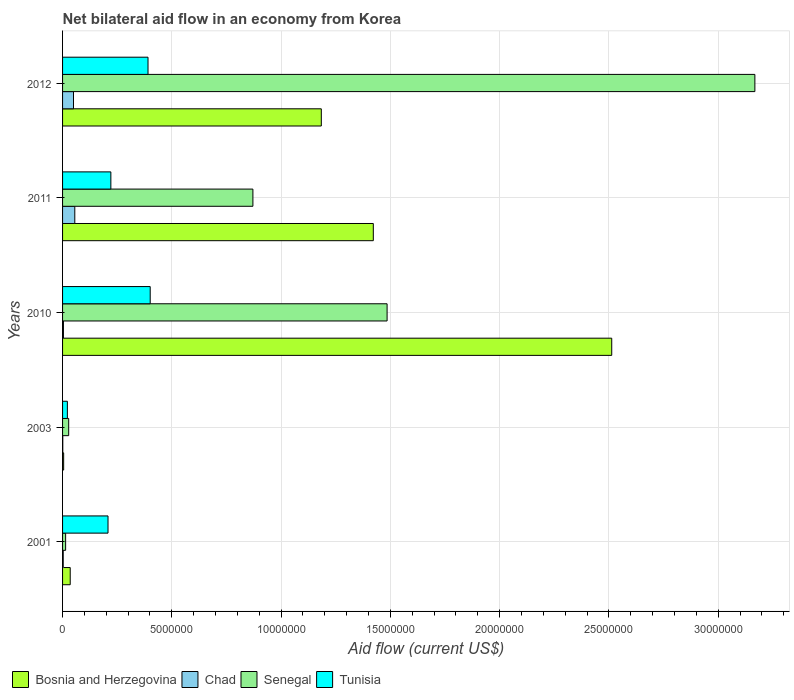How many different coloured bars are there?
Your response must be concise. 4. How many bars are there on the 2nd tick from the bottom?
Make the answer very short. 4. What is the label of the 2nd group of bars from the top?
Make the answer very short. 2011. In how many cases, is the number of bars for a given year not equal to the number of legend labels?
Provide a short and direct response. 0. What is the net bilateral aid flow in Bosnia and Herzegovina in 2012?
Make the answer very short. 1.18e+07. Across all years, what is the maximum net bilateral aid flow in Tunisia?
Offer a very short reply. 4.01e+06. What is the total net bilateral aid flow in Tunisia in the graph?
Provide a succinct answer. 1.24e+07. What is the difference between the net bilateral aid flow in Bosnia and Herzegovina in 2003 and that in 2012?
Your response must be concise. -1.18e+07. What is the difference between the net bilateral aid flow in Senegal in 2010 and the net bilateral aid flow in Tunisia in 2001?
Keep it short and to the point. 1.28e+07. What is the average net bilateral aid flow in Chad per year?
Your answer should be very brief. 2.28e+05. In the year 2010, what is the difference between the net bilateral aid flow in Chad and net bilateral aid flow in Senegal?
Provide a short and direct response. -1.48e+07. In how many years, is the net bilateral aid flow in Tunisia greater than 1000000 US$?
Provide a short and direct response. 4. Is the difference between the net bilateral aid flow in Chad in 2010 and 2012 greater than the difference between the net bilateral aid flow in Senegal in 2010 and 2012?
Your answer should be compact. Yes. What is the difference between the highest and the second highest net bilateral aid flow in Chad?
Your response must be concise. 6.00e+04. What is the difference between the highest and the lowest net bilateral aid flow in Bosnia and Herzegovina?
Provide a succinct answer. 2.51e+07. In how many years, is the net bilateral aid flow in Bosnia and Herzegovina greater than the average net bilateral aid flow in Bosnia and Herzegovina taken over all years?
Your answer should be compact. 3. Is it the case that in every year, the sum of the net bilateral aid flow in Senegal and net bilateral aid flow in Bosnia and Herzegovina is greater than the sum of net bilateral aid flow in Tunisia and net bilateral aid flow in Chad?
Give a very brief answer. No. What does the 1st bar from the top in 2012 represents?
Your answer should be very brief. Tunisia. What does the 3rd bar from the bottom in 2012 represents?
Your answer should be compact. Senegal. Is it the case that in every year, the sum of the net bilateral aid flow in Bosnia and Herzegovina and net bilateral aid flow in Chad is greater than the net bilateral aid flow in Tunisia?
Ensure brevity in your answer.  No. How many bars are there?
Provide a short and direct response. 20. Are all the bars in the graph horizontal?
Provide a succinct answer. Yes. How many years are there in the graph?
Give a very brief answer. 5. What is the difference between two consecutive major ticks on the X-axis?
Offer a very short reply. 5.00e+06. Are the values on the major ticks of X-axis written in scientific E-notation?
Provide a short and direct response. No. What is the title of the graph?
Your answer should be compact. Net bilateral aid flow in an economy from Korea. What is the Aid flow (current US$) in Senegal in 2001?
Provide a short and direct response. 1.40e+05. What is the Aid flow (current US$) of Tunisia in 2001?
Ensure brevity in your answer.  2.08e+06. What is the Aid flow (current US$) of Chad in 2003?
Provide a succinct answer. 10000. What is the Aid flow (current US$) in Bosnia and Herzegovina in 2010?
Offer a terse response. 2.51e+07. What is the Aid flow (current US$) of Chad in 2010?
Your answer should be very brief. 4.00e+04. What is the Aid flow (current US$) of Senegal in 2010?
Your answer should be compact. 1.48e+07. What is the Aid flow (current US$) of Tunisia in 2010?
Offer a very short reply. 4.01e+06. What is the Aid flow (current US$) in Bosnia and Herzegovina in 2011?
Ensure brevity in your answer.  1.42e+07. What is the Aid flow (current US$) in Chad in 2011?
Keep it short and to the point. 5.60e+05. What is the Aid flow (current US$) in Senegal in 2011?
Make the answer very short. 8.71e+06. What is the Aid flow (current US$) of Tunisia in 2011?
Provide a succinct answer. 2.21e+06. What is the Aid flow (current US$) of Bosnia and Herzegovina in 2012?
Your answer should be very brief. 1.18e+07. What is the Aid flow (current US$) in Chad in 2012?
Your response must be concise. 5.00e+05. What is the Aid flow (current US$) in Senegal in 2012?
Your answer should be compact. 3.17e+07. What is the Aid flow (current US$) of Tunisia in 2012?
Provide a succinct answer. 3.91e+06. Across all years, what is the maximum Aid flow (current US$) of Bosnia and Herzegovina?
Your answer should be compact. 2.51e+07. Across all years, what is the maximum Aid flow (current US$) in Chad?
Give a very brief answer. 5.60e+05. Across all years, what is the maximum Aid flow (current US$) of Senegal?
Your answer should be very brief. 3.17e+07. Across all years, what is the maximum Aid flow (current US$) of Tunisia?
Your answer should be very brief. 4.01e+06. Across all years, what is the minimum Aid flow (current US$) in Bosnia and Herzegovina?
Keep it short and to the point. 5.00e+04. Across all years, what is the minimum Aid flow (current US$) of Chad?
Give a very brief answer. 10000. Across all years, what is the minimum Aid flow (current US$) in Senegal?
Offer a very short reply. 1.40e+05. What is the total Aid flow (current US$) of Bosnia and Herzegovina in the graph?
Provide a succinct answer. 5.16e+07. What is the total Aid flow (current US$) of Chad in the graph?
Keep it short and to the point. 1.14e+06. What is the total Aid flow (current US$) of Senegal in the graph?
Give a very brief answer. 5.57e+07. What is the total Aid flow (current US$) in Tunisia in the graph?
Keep it short and to the point. 1.24e+07. What is the difference between the Aid flow (current US$) in Chad in 2001 and that in 2003?
Your response must be concise. 2.00e+04. What is the difference between the Aid flow (current US$) of Tunisia in 2001 and that in 2003?
Your response must be concise. 1.86e+06. What is the difference between the Aid flow (current US$) in Bosnia and Herzegovina in 2001 and that in 2010?
Provide a succinct answer. -2.48e+07. What is the difference between the Aid flow (current US$) in Chad in 2001 and that in 2010?
Your answer should be compact. -10000. What is the difference between the Aid flow (current US$) of Senegal in 2001 and that in 2010?
Ensure brevity in your answer.  -1.47e+07. What is the difference between the Aid flow (current US$) of Tunisia in 2001 and that in 2010?
Give a very brief answer. -1.93e+06. What is the difference between the Aid flow (current US$) in Bosnia and Herzegovina in 2001 and that in 2011?
Provide a succinct answer. -1.39e+07. What is the difference between the Aid flow (current US$) in Chad in 2001 and that in 2011?
Your response must be concise. -5.30e+05. What is the difference between the Aid flow (current US$) in Senegal in 2001 and that in 2011?
Provide a short and direct response. -8.57e+06. What is the difference between the Aid flow (current US$) in Tunisia in 2001 and that in 2011?
Your response must be concise. -1.30e+05. What is the difference between the Aid flow (current US$) in Bosnia and Herzegovina in 2001 and that in 2012?
Provide a short and direct response. -1.15e+07. What is the difference between the Aid flow (current US$) in Chad in 2001 and that in 2012?
Provide a short and direct response. -4.70e+05. What is the difference between the Aid flow (current US$) of Senegal in 2001 and that in 2012?
Your response must be concise. -3.15e+07. What is the difference between the Aid flow (current US$) in Tunisia in 2001 and that in 2012?
Ensure brevity in your answer.  -1.83e+06. What is the difference between the Aid flow (current US$) in Bosnia and Herzegovina in 2003 and that in 2010?
Give a very brief answer. -2.51e+07. What is the difference between the Aid flow (current US$) in Senegal in 2003 and that in 2010?
Keep it short and to the point. -1.46e+07. What is the difference between the Aid flow (current US$) in Tunisia in 2003 and that in 2010?
Offer a terse response. -3.79e+06. What is the difference between the Aid flow (current US$) in Bosnia and Herzegovina in 2003 and that in 2011?
Your response must be concise. -1.42e+07. What is the difference between the Aid flow (current US$) in Chad in 2003 and that in 2011?
Ensure brevity in your answer.  -5.50e+05. What is the difference between the Aid flow (current US$) of Senegal in 2003 and that in 2011?
Offer a very short reply. -8.43e+06. What is the difference between the Aid flow (current US$) of Tunisia in 2003 and that in 2011?
Your answer should be compact. -1.99e+06. What is the difference between the Aid flow (current US$) in Bosnia and Herzegovina in 2003 and that in 2012?
Your answer should be very brief. -1.18e+07. What is the difference between the Aid flow (current US$) of Chad in 2003 and that in 2012?
Give a very brief answer. -4.90e+05. What is the difference between the Aid flow (current US$) of Senegal in 2003 and that in 2012?
Your response must be concise. -3.14e+07. What is the difference between the Aid flow (current US$) in Tunisia in 2003 and that in 2012?
Offer a terse response. -3.69e+06. What is the difference between the Aid flow (current US$) in Bosnia and Herzegovina in 2010 and that in 2011?
Provide a succinct answer. 1.09e+07. What is the difference between the Aid flow (current US$) in Chad in 2010 and that in 2011?
Keep it short and to the point. -5.20e+05. What is the difference between the Aid flow (current US$) of Senegal in 2010 and that in 2011?
Your answer should be compact. 6.14e+06. What is the difference between the Aid flow (current US$) of Tunisia in 2010 and that in 2011?
Your answer should be very brief. 1.80e+06. What is the difference between the Aid flow (current US$) in Bosnia and Herzegovina in 2010 and that in 2012?
Ensure brevity in your answer.  1.33e+07. What is the difference between the Aid flow (current US$) in Chad in 2010 and that in 2012?
Offer a very short reply. -4.60e+05. What is the difference between the Aid flow (current US$) of Senegal in 2010 and that in 2012?
Provide a short and direct response. -1.68e+07. What is the difference between the Aid flow (current US$) in Bosnia and Herzegovina in 2011 and that in 2012?
Give a very brief answer. 2.38e+06. What is the difference between the Aid flow (current US$) in Senegal in 2011 and that in 2012?
Your answer should be compact. -2.30e+07. What is the difference between the Aid flow (current US$) in Tunisia in 2011 and that in 2012?
Provide a succinct answer. -1.70e+06. What is the difference between the Aid flow (current US$) of Bosnia and Herzegovina in 2001 and the Aid flow (current US$) of Senegal in 2003?
Offer a very short reply. 7.00e+04. What is the difference between the Aid flow (current US$) in Bosnia and Herzegovina in 2001 and the Aid flow (current US$) in Senegal in 2010?
Your answer should be very brief. -1.45e+07. What is the difference between the Aid flow (current US$) in Bosnia and Herzegovina in 2001 and the Aid flow (current US$) in Tunisia in 2010?
Offer a terse response. -3.66e+06. What is the difference between the Aid flow (current US$) in Chad in 2001 and the Aid flow (current US$) in Senegal in 2010?
Your answer should be very brief. -1.48e+07. What is the difference between the Aid flow (current US$) of Chad in 2001 and the Aid flow (current US$) of Tunisia in 2010?
Ensure brevity in your answer.  -3.98e+06. What is the difference between the Aid flow (current US$) in Senegal in 2001 and the Aid flow (current US$) in Tunisia in 2010?
Make the answer very short. -3.87e+06. What is the difference between the Aid flow (current US$) of Bosnia and Herzegovina in 2001 and the Aid flow (current US$) of Chad in 2011?
Keep it short and to the point. -2.10e+05. What is the difference between the Aid flow (current US$) in Bosnia and Herzegovina in 2001 and the Aid flow (current US$) in Senegal in 2011?
Offer a terse response. -8.36e+06. What is the difference between the Aid flow (current US$) in Bosnia and Herzegovina in 2001 and the Aid flow (current US$) in Tunisia in 2011?
Keep it short and to the point. -1.86e+06. What is the difference between the Aid flow (current US$) in Chad in 2001 and the Aid flow (current US$) in Senegal in 2011?
Offer a very short reply. -8.68e+06. What is the difference between the Aid flow (current US$) in Chad in 2001 and the Aid flow (current US$) in Tunisia in 2011?
Provide a short and direct response. -2.18e+06. What is the difference between the Aid flow (current US$) of Senegal in 2001 and the Aid flow (current US$) of Tunisia in 2011?
Keep it short and to the point. -2.07e+06. What is the difference between the Aid flow (current US$) in Bosnia and Herzegovina in 2001 and the Aid flow (current US$) in Senegal in 2012?
Ensure brevity in your answer.  -3.13e+07. What is the difference between the Aid flow (current US$) of Bosnia and Herzegovina in 2001 and the Aid flow (current US$) of Tunisia in 2012?
Offer a very short reply. -3.56e+06. What is the difference between the Aid flow (current US$) in Chad in 2001 and the Aid flow (current US$) in Senegal in 2012?
Give a very brief answer. -3.16e+07. What is the difference between the Aid flow (current US$) in Chad in 2001 and the Aid flow (current US$) in Tunisia in 2012?
Make the answer very short. -3.88e+06. What is the difference between the Aid flow (current US$) in Senegal in 2001 and the Aid flow (current US$) in Tunisia in 2012?
Ensure brevity in your answer.  -3.77e+06. What is the difference between the Aid flow (current US$) in Bosnia and Herzegovina in 2003 and the Aid flow (current US$) in Senegal in 2010?
Provide a succinct answer. -1.48e+07. What is the difference between the Aid flow (current US$) in Bosnia and Herzegovina in 2003 and the Aid flow (current US$) in Tunisia in 2010?
Provide a short and direct response. -3.96e+06. What is the difference between the Aid flow (current US$) in Chad in 2003 and the Aid flow (current US$) in Senegal in 2010?
Keep it short and to the point. -1.48e+07. What is the difference between the Aid flow (current US$) in Senegal in 2003 and the Aid flow (current US$) in Tunisia in 2010?
Your response must be concise. -3.73e+06. What is the difference between the Aid flow (current US$) of Bosnia and Herzegovina in 2003 and the Aid flow (current US$) of Chad in 2011?
Offer a very short reply. -5.10e+05. What is the difference between the Aid flow (current US$) in Bosnia and Herzegovina in 2003 and the Aid flow (current US$) in Senegal in 2011?
Your answer should be very brief. -8.66e+06. What is the difference between the Aid flow (current US$) in Bosnia and Herzegovina in 2003 and the Aid flow (current US$) in Tunisia in 2011?
Your answer should be compact. -2.16e+06. What is the difference between the Aid flow (current US$) in Chad in 2003 and the Aid flow (current US$) in Senegal in 2011?
Make the answer very short. -8.70e+06. What is the difference between the Aid flow (current US$) in Chad in 2003 and the Aid flow (current US$) in Tunisia in 2011?
Offer a terse response. -2.20e+06. What is the difference between the Aid flow (current US$) of Senegal in 2003 and the Aid flow (current US$) of Tunisia in 2011?
Provide a short and direct response. -1.93e+06. What is the difference between the Aid flow (current US$) in Bosnia and Herzegovina in 2003 and the Aid flow (current US$) in Chad in 2012?
Provide a short and direct response. -4.50e+05. What is the difference between the Aid flow (current US$) in Bosnia and Herzegovina in 2003 and the Aid flow (current US$) in Senegal in 2012?
Make the answer very short. -3.16e+07. What is the difference between the Aid flow (current US$) of Bosnia and Herzegovina in 2003 and the Aid flow (current US$) of Tunisia in 2012?
Give a very brief answer. -3.86e+06. What is the difference between the Aid flow (current US$) of Chad in 2003 and the Aid flow (current US$) of Senegal in 2012?
Your response must be concise. -3.17e+07. What is the difference between the Aid flow (current US$) in Chad in 2003 and the Aid flow (current US$) in Tunisia in 2012?
Ensure brevity in your answer.  -3.90e+06. What is the difference between the Aid flow (current US$) of Senegal in 2003 and the Aid flow (current US$) of Tunisia in 2012?
Keep it short and to the point. -3.63e+06. What is the difference between the Aid flow (current US$) in Bosnia and Herzegovina in 2010 and the Aid flow (current US$) in Chad in 2011?
Your answer should be compact. 2.46e+07. What is the difference between the Aid flow (current US$) in Bosnia and Herzegovina in 2010 and the Aid flow (current US$) in Senegal in 2011?
Make the answer very short. 1.64e+07. What is the difference between the Aid flow (current US$) in Bosnia and Herzegovina in 2010 and the Aid flow (current US$) in Tunisia in 2011?
Your response must be concise. 2.29e+07. What is the difference between the Aid flow (current US$) in Chad in 2010 and the Aid flow (current US$) in Senegal in 2011?
Ensure brevity in your answer.  -8.67e+06. What is the difference between the Aid flow (current US$) of Chad in 2010 and the Aid flow (current US$) of Tunisia in 2011?
Offer a terse response. -2.17e+06. What is the difference between the Aid flow (current US$) of Senegal in 2010 and the Aid flow (current US$) of Tunisia in 2011?
Ensure brevity in your answer.  1.26e+07. What is the difference between the Aid flow (current US$) of Bosnia and Herzegovina in 2010 and the Aid flow (current US$) of Chad in 2012?
Provide a succinct answer. 2.46e+07. What is the difference between the Aid flow (current US$) of Bosnia and Herzegovina in 2010 and the Aid flow (current US$) of Senegal in 2012?
Your response must be concise. -6.55e+06. What is the difference between the Aid flow (current US$) of Bosnia and Herzegovina in 2010 and the Aid flow (current US$) of Tunisia in 2012?
Provide a short and direct response. 2.12e+07. What is the difference between the Aid flow (current US$) of Chad in 2010 and the Aid flow (current US$) of Senegal in 2012?
Ensure brevity in your answer.  -3.16e+07. What is the difference between the Aid flow (current US$) in Chad in 2010 and the Aid flow (current US$) in Tunisia in 2012?
Your response must be concise. -3.87e+06. What is the difference between the Aid flow (current US$) in Senegal in 2010 and the Aid flow (current US$) in Tunisia in 2012?
Your response must be concise. 1.09e+07. What is the difference between the Aid flow (current US$) in Bosnia and Herzegovina in 2011 and the Aid flow (current US$) in Chad in 2012?
Offer a terse response. 1.37e+07. What is the difference between the Aid flow (current US$) in Bosnia and Herzegovina in 2011 and the Aid flow (current US$) in Senegal in 2012?
Your answer should be compact. -1.75e+07. What is the difference between the Aid flow (current US$) of Bosnia and Herzegovina in 2011 and the Aid flow (current US$) of Tunisia in 2012?
Make the answer very short. 1.03e+07. What is the difference between the Aid flow (current US$) in Chad in 2011 and the Aid flow (current US$) in Senegal in 2012?
Your answer should be compact. -3.11e+07. What is the difference between the Aid flow (current US$) in Chad in 2011 and the Aid flow (current US$) in Tunisia in 2012?
Give a very brief answer. -3.35e+06. What is the difference between the Aid flow (current US$) of Senegal in 2011 and the Aid flow (current US$) of Tunisia in 2012?
Make the answer very short. 4.80e+06. What is the average Aid flow (current US$) of Bosnia and Herzegovina per year?
Your response must be concise. 1.03e+07. What is the average Aid flow (current US$) of Chad per year?
Offer a very short reply. 2.28e+05. What is the average Aid flow (current US$) of Senegal per year?
Offer a terse response. 1.11e+07. What is the average Aid flow (current US$) of Tunisia per year?
Keep it short and to the point. 2.49e+06. In the year 2001, what is the difference between the Aid flow (current US$) of Bosnia and Herzegovina and Aid flow (current US$) of Senegal?
Your answer should be compact. 2.10e+05. In the year 2001, what is the difference between the Aid flow (current US$) of Bosnia and Herzegovina and Aid flow (current US$) of Tunisia?
Provide a succinct answer. -1.73e+06. In the year 2001, what is the difference between the Aid flow (current US$) in Chad and Aid flow (current US$) in Senegal?
Offer a very short reply. -1.10e+05. In the year 2001, what is the difference between the Aid flow (current US$) in Chad and Aid flow (current US$) in Tunisia?
Your answer should be very brief. -2.05e+06. In the year 2001, what is the difference between the Aid flow (current US$) in Senegal and Aid flow (current US$) in Tunisia?
Give a very brief answer. -1.94e+06. In the year 2003, what is the difference between the Aid flow (current US$) in Bosnia and Herzegovina and Aid flow (current US$) in Chad?
Ensure brevity in your answer.  4.00e+04. In the year 2003, what is the difference between the Aid flow (current US$) of Bosnia and Herzegovina and Aid flow (current US$) of Senegal?
Make the answer very short. -2.30e+05. In the year 2003, what is the difference between the Aid flow (current US$) of Senegal and Aid flow (current US$) of Tunisia?
Keep it short and to the point. 6.00e+04. In the year 2010, what is the difference between the Aid flow (current US$) of Bosnia and Herzegovina and Aid flow (current US$) of Chad?
Offer a terse response. 2.51e+07. In the year 2010, what is the difference between the Aid flow (current US$) of Bosnia and Herzegovina and Aid flow (current US$) of Senegal?
Your answer should be compact. 1.03e+07. In the year 2010, what is the difference between the Aid flow (current US$) of Bosnia and Herzegovina and Aid flow (current US$) of Tunisia?
Your answer should be compact. 2.11e+07. In the year 2010, what is the difference between the Aid flow (current US$) of Chad and Aid flow (current US$) of Senegal?
Ensure brevity in your answer.  -1.48e+07. In the year 2010, what is the difference between the Aid flow (current US$) in Chad and Aid flow (current US$) in Tunisia?
Keep it short and to the point. -3.97e+06. In the year 2010, what is the difference between the Aid flow (current US$) of Senegal and Aid flow (current US$) of Tunisia?
Give a very brief answer. 1.08e+07. In the year 2011, what is the difference between the Aid flow (current US$) in Bosnia and Herzegovina and Aid flow (current US$) in Chad?
Offer a terse response. 1.37e+07. In the year 2011, what is the difference between the Aid flow (current US$) of Bosnia and Herzegovina and Aid flow (current US$) of Senegal?
Ensure brevity in your answer.  5.51e+06. In the year 2011, what is the difference between the Aid flow (current US$) of Bosnia and Herzegovina and Aid flow (current US$) of Tunisia?
Your answer should be very brief. 1.20e+07. In the year 2011, what is the difference between the Aid flow (current US$) of Chad and Aid flow (current US$) of Senegal?
Keep it short and to the point. -8.15e+06. In the year 2011, what is the difference between the Aid flow (current US$) of Chad and Aid flow (current US$) of Tunisia?
Provide a succinct answer. -1.65e+06. In the year 2011, what is the difference between the Aid flow (current US$) of Senegal and Aid flow (current US$) of Tunisia?
Your answer should be compact. 6.50e+06. In the year 2012, what is the difference between the Aid flow (current US$) of Bosnia and Herzegovina and Aid flow (current US$) of Chad?
Offer a terse response. 1.13e+07. In the year 2012, what is the difference between the Aid flow (current US$) in Bosnia and Herzegovina and Aid flow (current US$) in Senegal?
Offer a terse response. -1.98e+07. In the year 2012, what is the difference between the Aid flow (current US$) in Bosnia and Herzegovina and Aid flow (current US$) in Tunisia?
Provide a short and direct response. 7.93e+06. In the year 2012, what is the difference between the Aid flow (current US$) of Chad and Aid flow (current US$) of Senegal?
Keep it short and to the point. -3.12e+07. In the year 2012, what is the difference between the Aid flow (current US$) of Chad and Aid flow (current US$) of Tunisia?
Give a very brief answer. -3.41e+06. In the year 2012, what is the difference between the Aid flow (current US$) in Senegal and Aid flow (current US$) in Tunisia?
Keep it short and to the point. 2.78e+07. What is the ratio of the Aid flow (current US$) in Bosnia and Herzegovina in 2001 to that in 2003?
Your answer should be compact. 7. What is the ratio of the Aid flow (current US$) of Tunisia in 2001 to that in 2003?
Offer a very short reply. 9.45. What is the ratio of the Aid flow (current US$) in Bosnia and Herzegovina in 2001 to that in 2010?
Provide a short and direct response. 0.01. What is the ratio of the Aid flow (current US$) in Chad in 2001 to that in 2010?
Provide a short and direct response. 0.75. What is the ratio of the Aid flow (current US$) of Senegal in 2001 to that in 2010?
Make the answer very short. 0.01. What is the ratio of the Aid flow (current US$) in Tunisia in 2001 to that in 2010?
Your response must be concise. 0.52. What is the ratio of the Aid flow (current US$) of Bosnia and Herzegovina in 2001 to that in 2011?
Offer a terse response. 0.02. What is the ratio of the Aid flow (current US$) in Chad in 2001 to that in 2011?
Offer a very short reply. 0.05. What is the ratio of the Aid flow (current US$) in Senegal in 2001 to that in 2011?
Offer a terse response. 0.02. What is the ratio of the Aid flow (current US$) of Tunisia in 2001 to that in 2011?
Your answer should be compact. 0.94. What is the ratio of the Aid flow (current US$) in Bosnia and Herzegovina in 2001 to that in 2012?
Ensure brevity in your answer.  0.03. What is the ratio of the Aid flow (current US$) in Senegal in 2001 to that in 2012?
Give a very brief answer. 0. What is the ratio of the Aid flow (current US$) of Tunisia in 2001 to that in 2012?
Give a very brief answer. 0.53. What is the ratio of the Aid flow (current US$) in Bosnia and Herzegovina in 2003 to that in 2010?
Your answer should be very brief. 0. What is the ratio of the Aid flow (current US$) of Chad in 2003 to that in 2010?
Make the answer very short. 0.25. What is the ratio of the Aid flow (current US$) of Senegal in 2003 to that in 2010?
Your answer should be very brief. 0.02. What is the ratio of the Aid flow (current US$) in Tunisia in 2003 to that in 2010?
Provide a short and direct response. 0.05. What is the ratio of the Aid flow (current US$) of Bosnia and Herzegovina in 2003 to that in 2011?
Provide a short and direct response. 0. What is the ratio of the Aid flow (current US$) of Chad in 2003 to that in 2011?
Give a very brief answer. 0.02. What is the ratio of the Aid flow (current US$) in Senegal in 2003 to that in 2011?
Your response must be concise. 0.03. What is the ratio of the Aid flow (current US$) of Tunisia in 2003 to that in 2011?
Your response must be concise. 0.1. What is the ratio of the Aid flow (current US$) of Bosnia and Herzegovina in 2003 to that in 2012?
Your answer should be very brief. 0. What is the ratio of the Aid flow (current US$) in Senegal in 2003 to that in 2012?
Your answer should be compact. 0.01. What is the ratio of the Aid flow (current US$) in Tunisia in 2003 to that in 2012?
Offer a very short reply. 0.06. What is the ratio of the Aid flow (current US$) in Bosnia and Herzegovina in 2010 to that in 2011?
Your response must be concise. 1.77. What is the ratio of the Aid flow (current US$) of Chad in 2010 to that in 2011?
Provide a succinct answer. 0.07. What is the ratio of the Aid flow (current US$) of Senegal in 2010 to that in 2011?
Give a very brief answer. 1.7. What is the ratio of the Aid flow (current US$) in Tunisia in 2010 to that in 2011?
Provide a short and direct response. 1.81. What is the ratio of the Aid flow (current US$) in Bosnia and Herzegovina in 2010 to that in 2012?
Your response must be concise. 2.12. What is the ratio of the Aid flow (current US$) in Senegal in 2010 to that in 2012?
Offer a very short reply. 0.47. What is the ratio of the Aid flow (current US$) in Tunisia in 2010 to that in 2012?
Provide a succinct answer. 1.03. What is the ratio of the Aid flow (current US$) in Bosnia and Herzegovina in 2011 to that in 2012?
Your answer should be very brief. 1.2. What is the ratio of the Aid flow (current US$) of Chad in 2011 to that in 2012?
Keep it short and to the point. 1.12. What is the ratio of the Aid flow (current US$) of Senegal in 2011 to that in 2012?
Your answer should be very brief. 0.27. What is the ratio of the Aid flow (current US$) of Tunisia in 2011 to that in 2012?
Offer a terse response. 0.57. What is the difference between the highest and the second highest Aid flow (current US$) of Bosnia and Herzegovina?
Give a very brief answer. 1.09e+07. What is the difference between the highest and the second highest Aid flow (current US$) in Senegal?
Provide a succinct answer. 1.68e+07. What is the difference between the highest and the second highest Aid flow (current US$) in Tunisia?
Your response must be concise. 1.00e+05. What is the difference between the highest and the lowest Aid flow (current US$) of Bosnia and Herzegovina?
Offer a terse response. 2.51e+07. What is the difference between the highest and the lowest Aid flow (current US$) of Senegal?
Give a very brief answer. 3.15e+07. What is the difference between the highest and the lowest Aid flow (current US$) of Tunisia?
Offer a very short reply. 3.79e+06. 